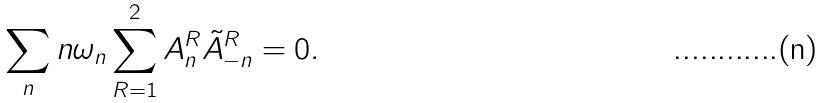<formula> <loc_0><loc_0><loc_500><loc_500>\sum _ { n } n \omega _ { n } \sum _ { R = 1 } ^ { 2 } A _ { n } ^ { R } \tilde { A } _ { - n } ^ { R } = 0 .</formula> 